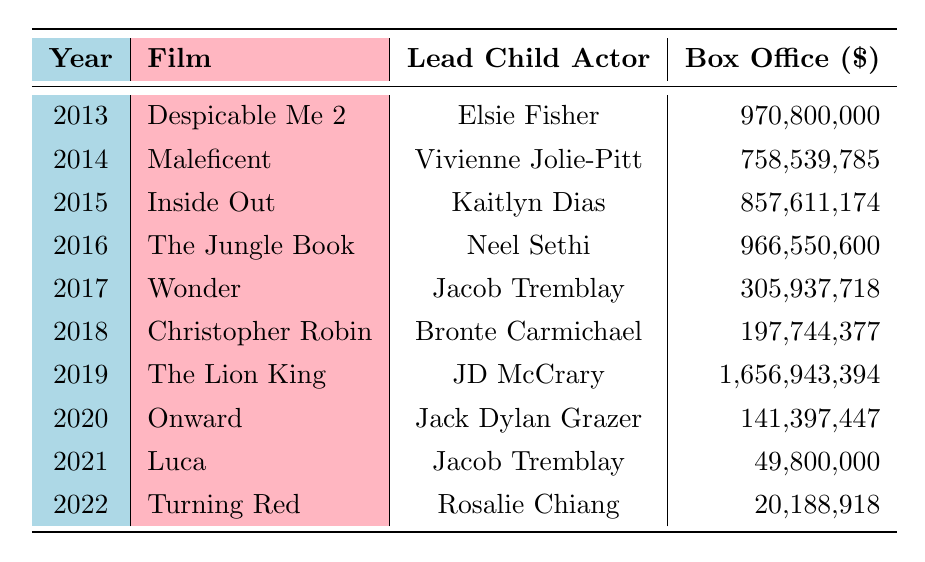What film had the highest box office earnings in 2019? Referring to the table, "The Lion King" (2019) has the highest box office earnings of 1,656,943,394.
Answer: The Lion King How much did "Wonder" earn at the box office in 2017? The table indicates that "Wonder" earned 305,937,718 in 2017.
Answer: 305,937,718 What is the total box office earnings of the films from 2013 to 2016? To find this, we sum the box office earnings for each film from 2013 to 2016: 970,800,000 (2013) + 758,539,785 (2014) + 857,611,174 (2015) + 966,550,600 (2016) = 3,553,501,559.
Answer: 3,553,501,559 Did any film released in 2020 have a higher box office than "Wonder"? Comparing box office earnings, "Onward" (2020) earned 141,397,447, which is less than "Wonder's" 305,937,718 (2017), so the answer is no.
Answer: No What year saw the release of "Despicable Me 2"? Looking at the table, "Despicable Me 2" was released in 2013.
Answer: 2013 Which film features Jacob Tremblay as the lead child actor? The table shows that Jacob Tremblay acted in "Wonder" (2017) and "Luca" (2021).
Answer: Wonder and Luca What is the average box office earnings for the films from 2013 to 2022? To calculate the average, we first sum all the box office earnings: 970,800,000 + 758,539,785 + 857,611,174 + 966,550,600 + 305,937,718 + 197,744,377 + 1,656,943,394 + 141,397,447 + 49,800,000 + 20,188,918 = 5,854,112,513. Then, we divide by the number of films (10) to get the average: 5,854,112,513 / 10 = 585,411,251.3.
Answer: 585,411,251.3 In which year was the lowest box office earnings recorded, and how much did it earn? By examining the box office earnings, "Turning Red" (2022) has the lowest earnings of 20,188,918, making 2022 the year with the lowest earnings.
Answer: 2022, 20,188,918 Was "Inside Out" more successful financially than "Onward"? Comparing the earnings, "Inside Out" earned 857,611,174 while "Onward" earned 141,397,447, showing that "Inside Out" was indeed more successful.
Answer: Yes How many films listed had box office earnings over 900 million? From the table, we find that "Despicable Me 2," "The Jungle Book," and "The Lion King" all had earnings over 900 million. This gives us a total of three films.
Answer: 3 Which lead child actor appeared in films with the highest and lowest box office earnings? "JD McCrary" in "The Lion King" has the highest earnings at 1,656,943,394 while "Rosalie Chiang" in "Turning Red" has the lowest earnings at 20,188,918.
Answer: JD McCrary and Rosalie Chiang 